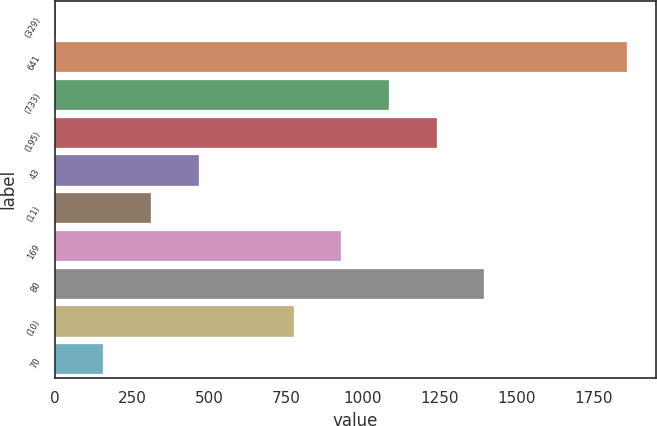<chart> <loc_0><loc_0><loc_500><loc_500><bar_chart><fcel>(329)<fcel>641<fcel>(733)<fcel>(195)<fcel>43<fcel>(11)<fcel>169<fcel>80<fcel>(10)<fcel>70<nl><fcel>2<fcel>1857.2<fcel>1084.2<fcel>1238.8<fcel>465.8<fcel>311.2<fcel>929.6<fcel>1393.4<fcel>775<fcel>156.6<nl></chart> 